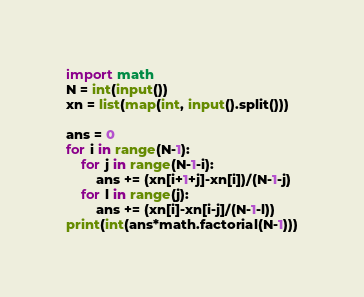<code> <loc_0><loc_0><loc_500><loc_500><_Python_>import math
N = int(input())
xn = list(map(int, input().split()))

ans = 0
for i in range(N-1):
    for j in range(N-1-i):
        ans += (xn[i+1+j]-xn[i])/(N-1-j)
    for l in range(j):
        ans += (xn[i]-xn[i-j]/(N-1-l))
print(int(ans*math.factorial(N-1)))</code> 